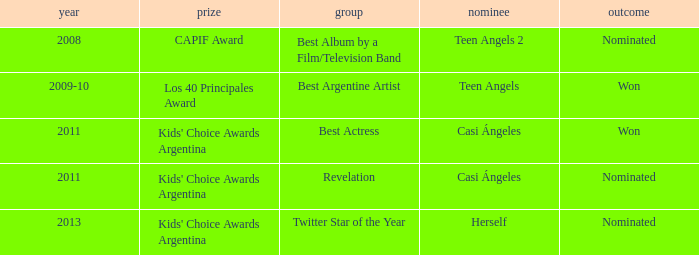What year saw an award in the category of Revelation? 2011.0. 